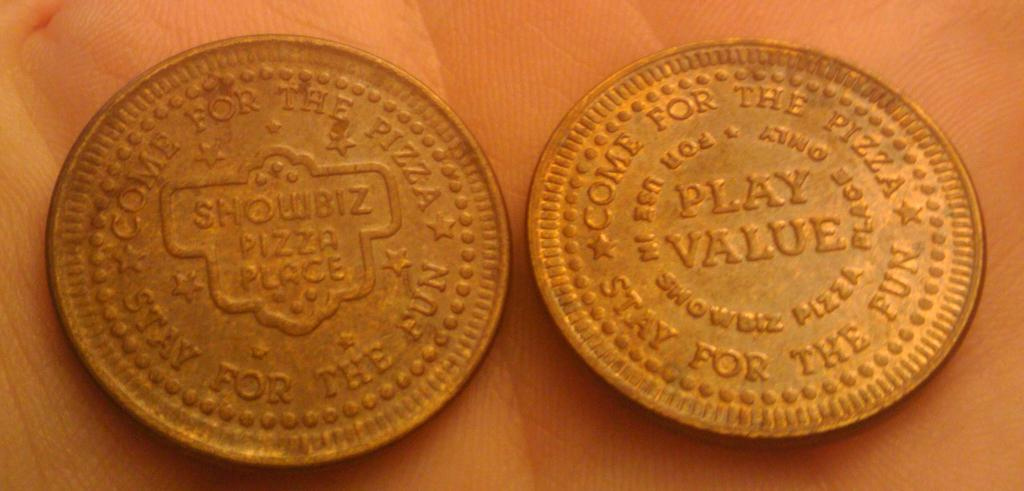<image>
Write a terse but informative summary of the picture. The front and back of a gold coin where one side says play value. 